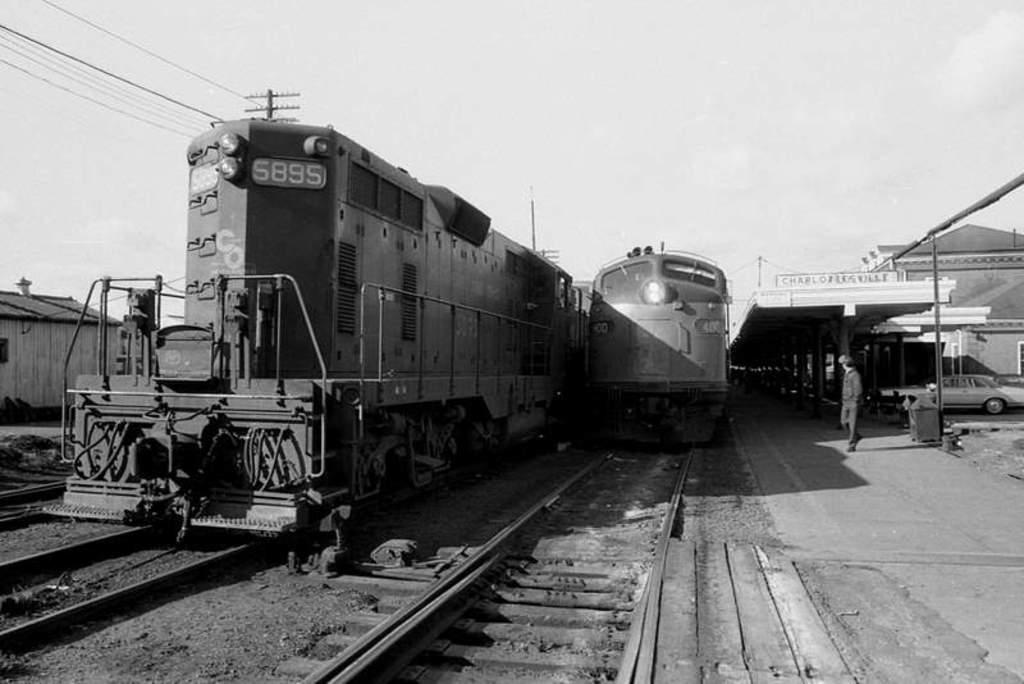What type of vehicles can be seen in the image? There are trains on tracks in the image. What object is present for waste disposal? There is a bin in the image. What structures can be seen in the image that are related to power or communication? There are rods and wires in the image. Can you describe the person in the image? There is a person walking in the image. What type of transportation is also visible in the image? There is a car in the image. What type of buildings can be seen in the background of the image? There is a shed, a house, and a building in the background of the image. What other structures can be seen in the background of the image? There are poles in the background of the image. What part of the natural environment is visible in the background of the image? The sky is visible in the background of the image. What type of current is flowing through the wires in the image? There is no information about the type of current flowing through the wires in the image. What kind of haircut does the person walking in the image have? The image does not provide enough detail to determine the person's haircut. Is there any indication of an attack happening in the image? There is no indication of an attack in the image. 